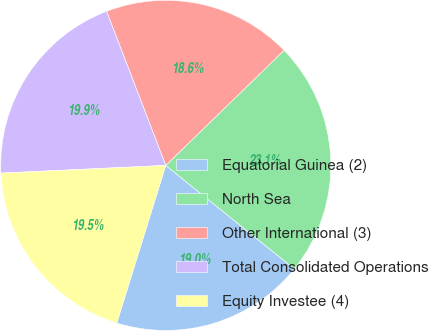<chart> <loc_0><loc_0><loc_500><loc_500><pie_chart><fcel>Equatorial Guinea (2)<fcel>North Sea<fcel>Other International (3)<fcel>Total Consolidated Operations<fcel>Equity Investee (4)<nl><fcel>19.01%<fcel>23.07%<fcel>18.56%<fcel>19.91%<fcel>19.46%<nl></chart> 